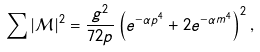Convert formula to latex. <formula><loc_0><loc_0><loc_500><loc_500>\sum | \mathcal { M } | ^ { 2 } = \frac { g ^ { 2 } } { 7 2 p } \left ( e ^ { - \alpha p ^ { 4 } } + 2 e ^ { - \alpha m ^ { 4 } } \right ) ^ { 2 } ,</formula> 